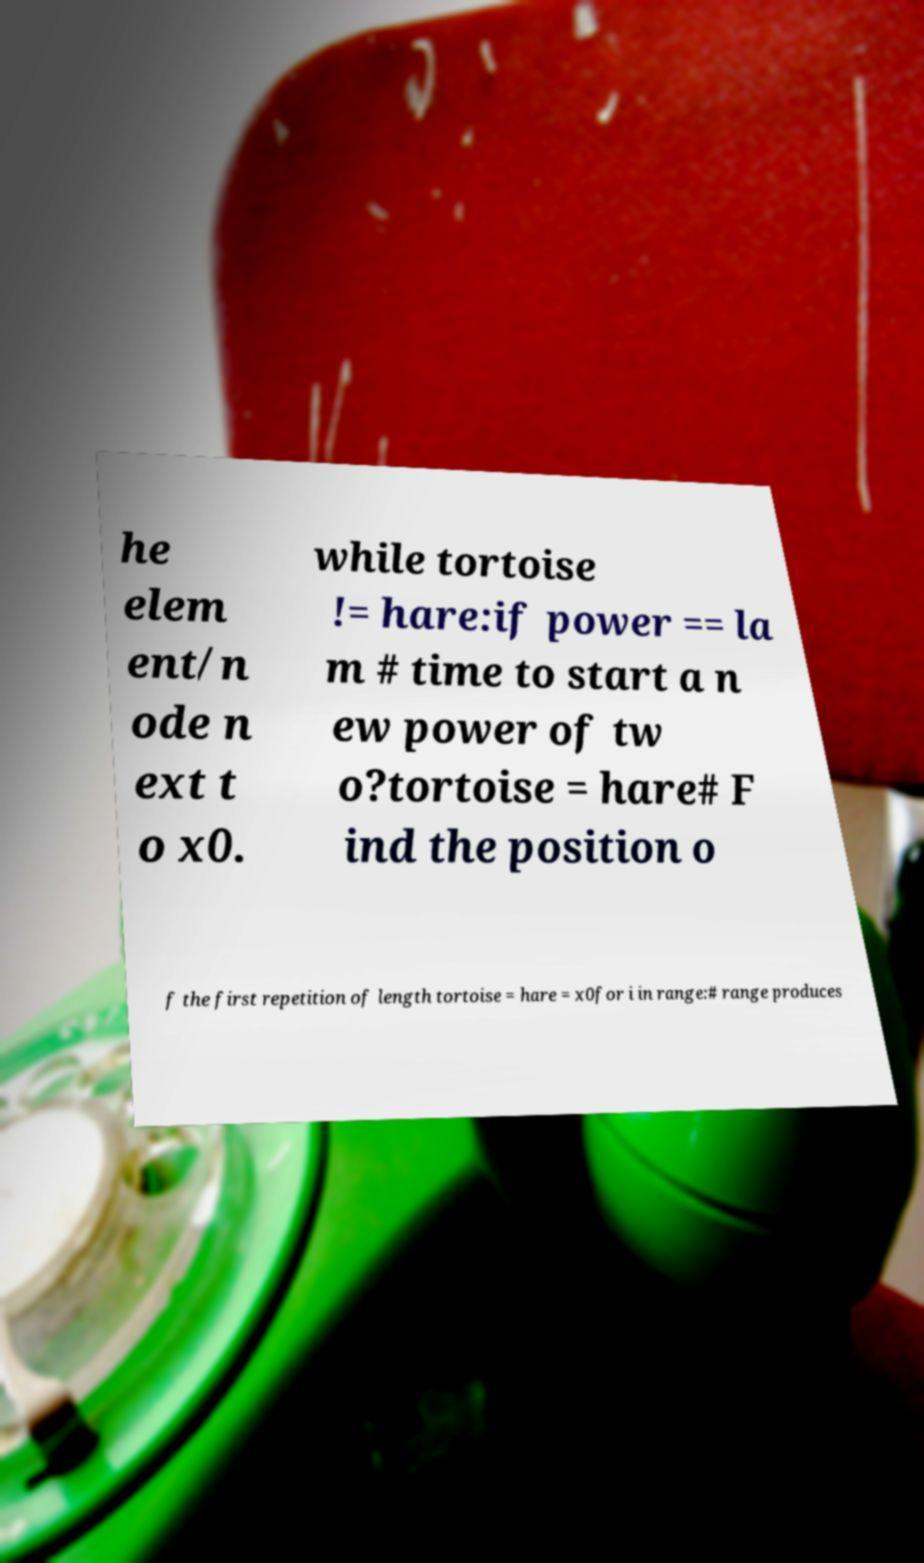There's text embedded in this image that I need extracted. Can you transcribe it verbatim? he elem ent/n ode n ext t o x0. while tortoise != hare:if power == la m # time to start a n ew power of tw o?tortoise = hare# F ind the position o f the first repetition of length tortoise = hare = x0for i in range:# range produces 